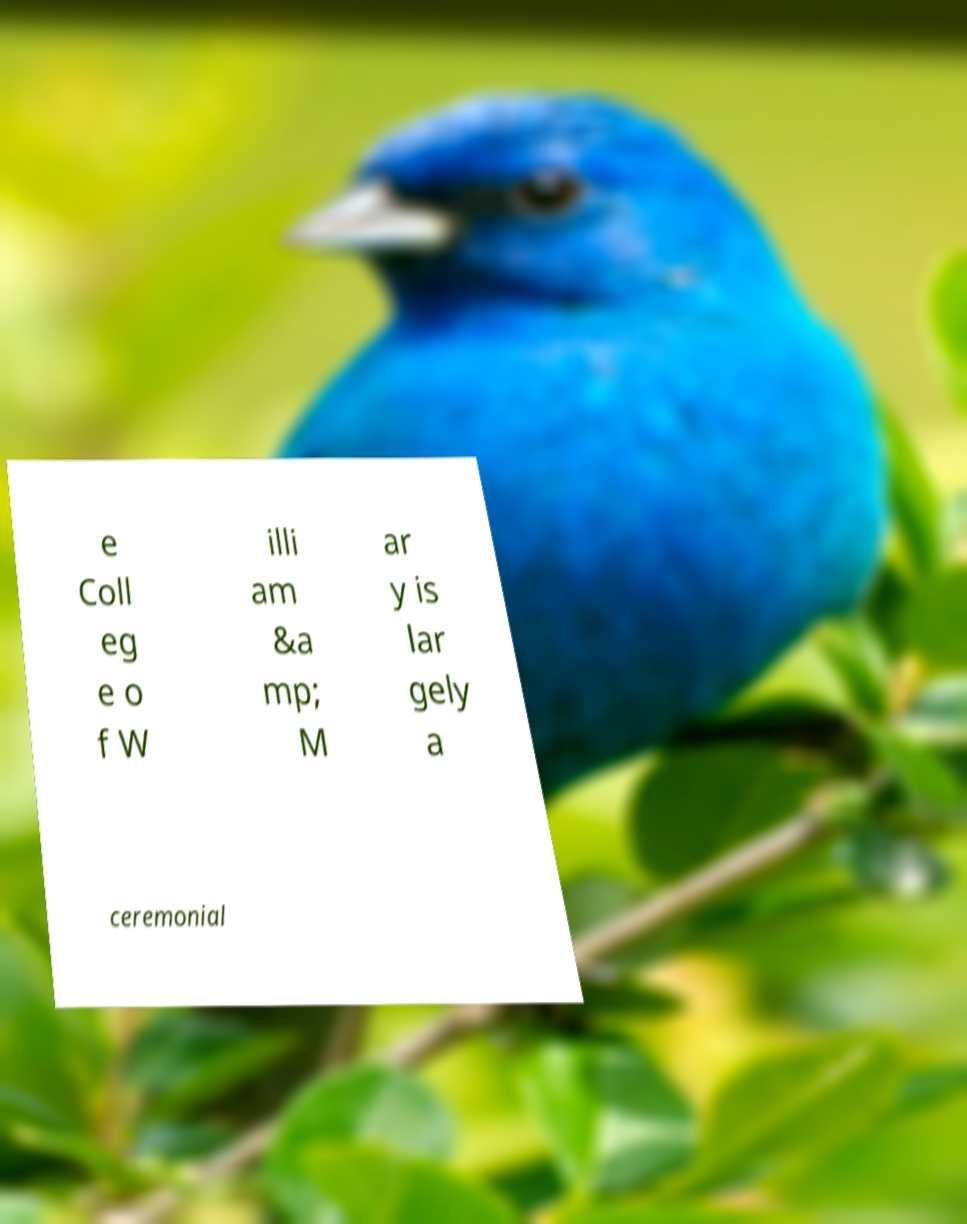Could you assist in decoding the text presented in this image and type it out clearly? e Coll eg e o f W illi am &a mp; M ar y is lar gely a ceremonial 